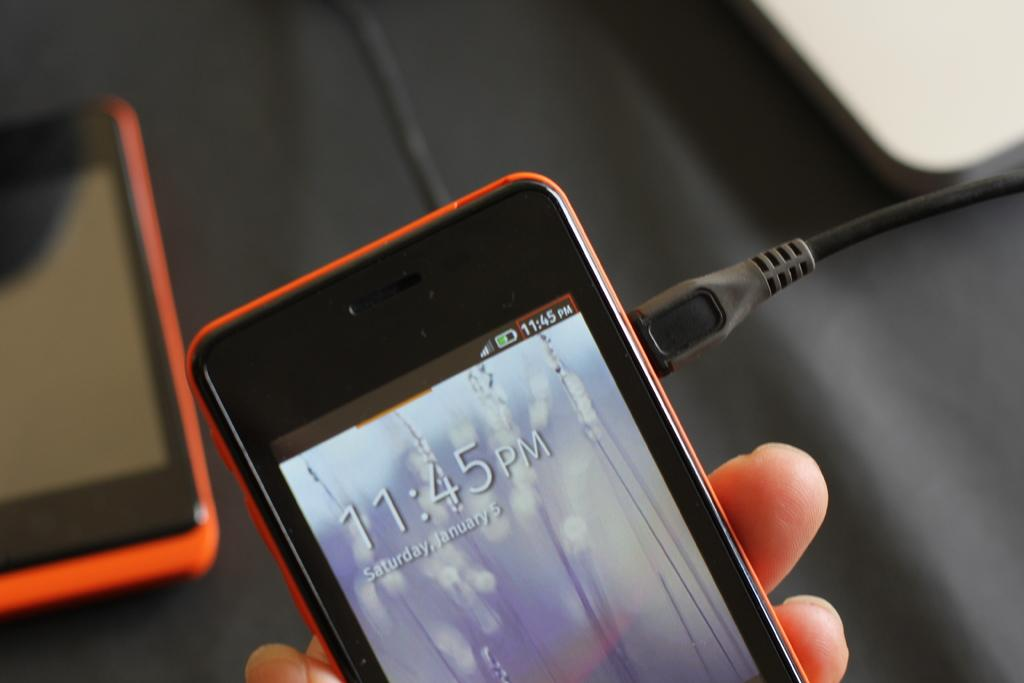<image>
Give a short and clear explanation of the subsequent image. A charging phone is on its lock screen and shows the time as 11:45 PM. 